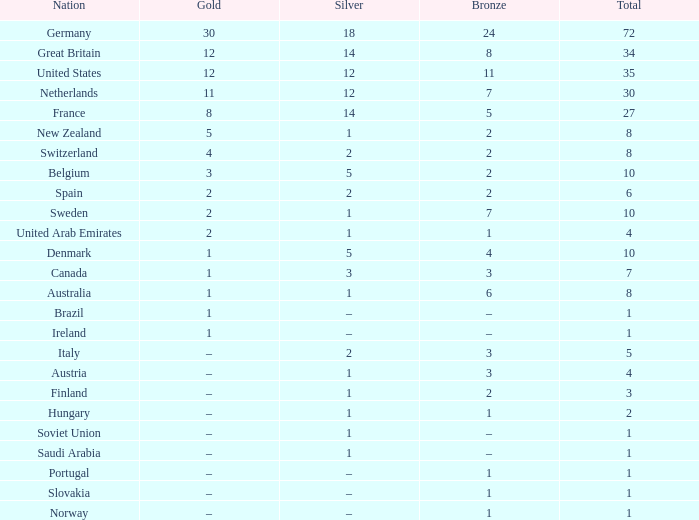What is the overall sum of total when silver equals 1 and bronze equals 7? 1.0. 